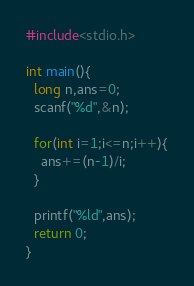Convert code to text. <code><loc_0><loc_0><loc_500><loc_500><_C_>#include<stdio.h>

int main(){
  long n,ans=0;
  scanf("%d",&n);
  
  for(int i=1;i<=n;i++){
    ans+=(n-1)/i;
  }
  
  printf("%ld",ans);
  return 0;
}</code> 